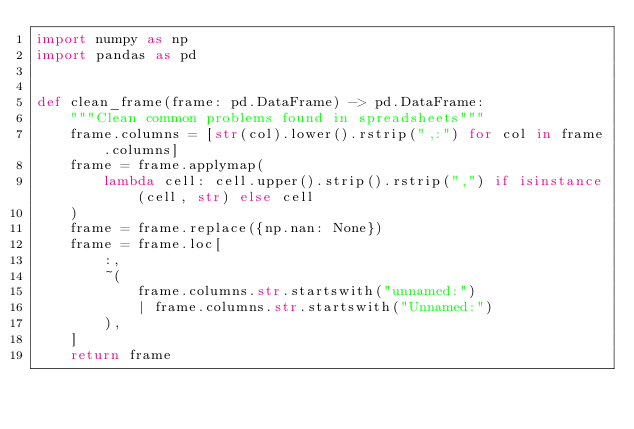<code> <loc_0><loc_0><loc_500><loc_500><_Python_>import numpy as np
import pandas as pd


def clean_frame(frame: pd.DataFrame) -> pd.DataFrame:
    """Clean common problems found in spreadsheets"""
    frame.columns = [str(col).lower().rstrip(",:") for col in frame.columns]
    frame = frame.applymap(
        lambda cell: cell.upper().strip().rstrip(",") if isinstance(cell, str) else cell
    )
    frame = frame.replace({np.nan: None})
    frame = frame.loc[
        :,
        ~(
            frame.columns.str.startswith("unnamed:")
            | frame.columns.str.startswith("Unnamed:")
        ),
    ]
    return frame
</code> 